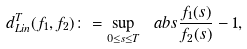Convert formula to latex. <formula><loc_0><loc_0><loc_500><loc_500>d _ { L i n } ^ { T } ( f _ { 1 } , f _ { 2 } ) \colon = \sup _ { 0 \leq s \leq T } \ a b s { \frac { f _ { 1 } ( s ) } { f _ { 2 } ( s ) } - 1 } ,</formula> 